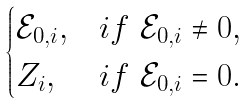Convert formula to latex. <formula><loc_0><loc_0><loc_500><loc_500>\begin{cases} \mathcal { E } _ { 0 , i } , & i f \ \mathcal { E } _ { 0 , i } \neq 0 , \\ Z _ { i } , & i f \ \mathcal { E } _ { 0 , i } = 0 . \end{cases}</formula> 